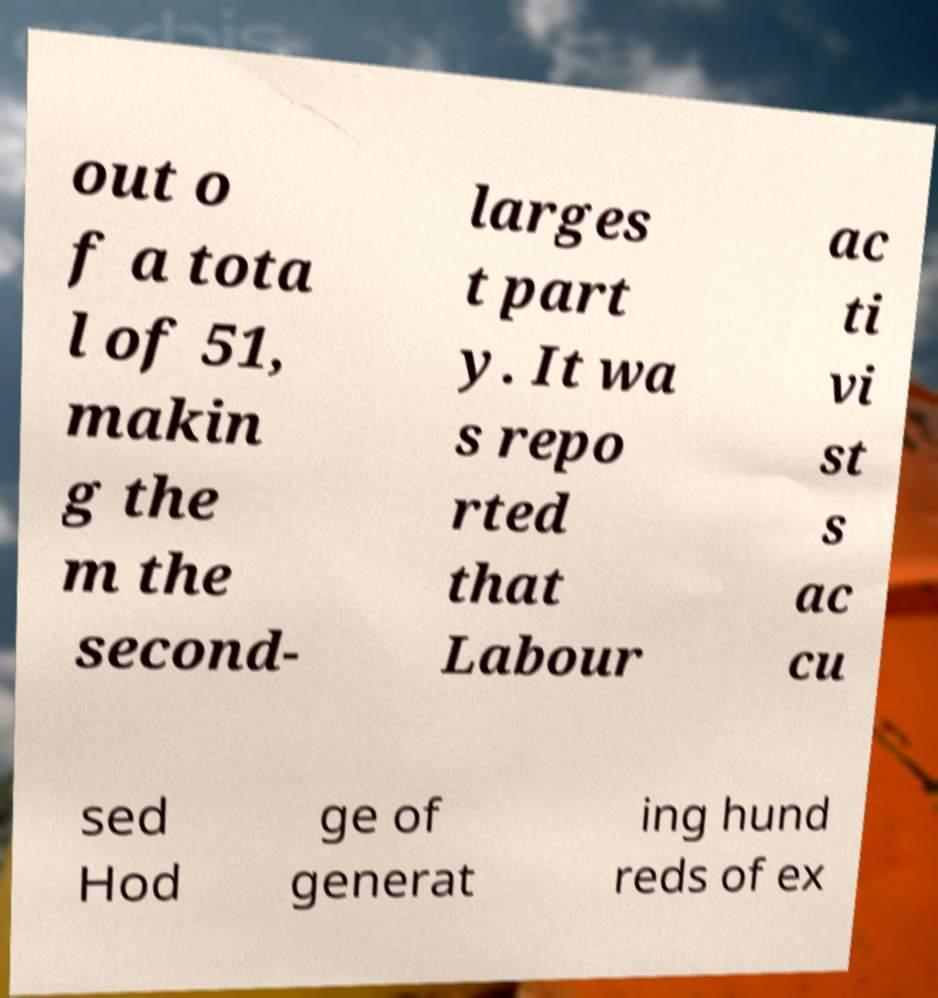Can you accurately transcribe the text from the provided image for me? out o f a tota l of 51, makin g the m the second- larges t part y. It wa s repo rted that Labour ac ti vi st s ac cu sed Hod ge of generat ing hund reds of ex 